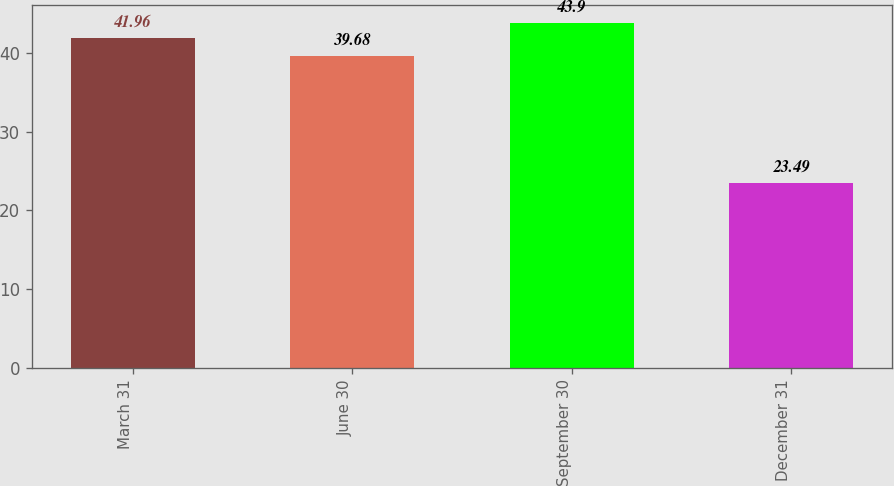Convert chart to OTSL. <chart><loc_0><loc_0><loc_500><loc_500><bar_chart><fcel>March 31<fcel>June 30<fcel>September 30<fcel>December 31<nl><fcel>41.96<fcel>39.68<fcel>43.9<fcel>23.49<nl></chart> 